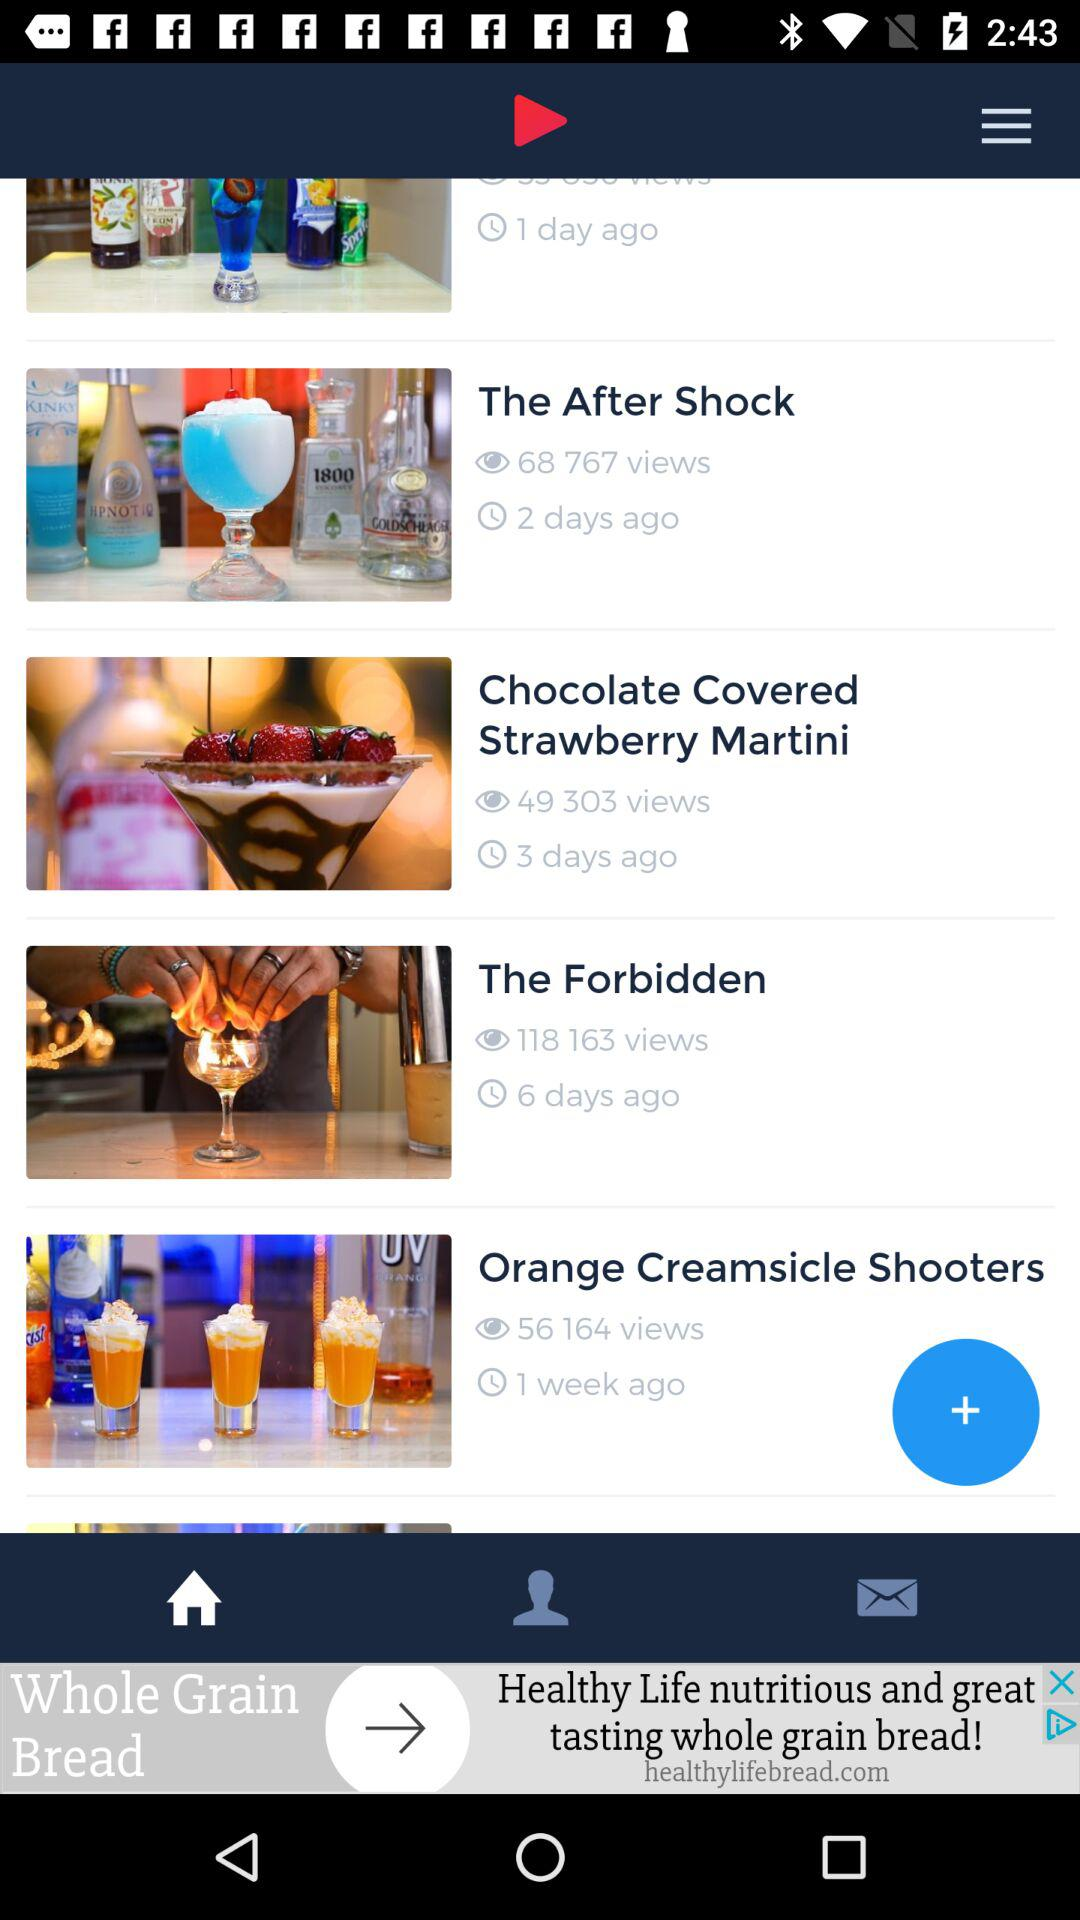When was the video "The After Shock" posted? The video "The After Shock" was posted 2 days ago. 